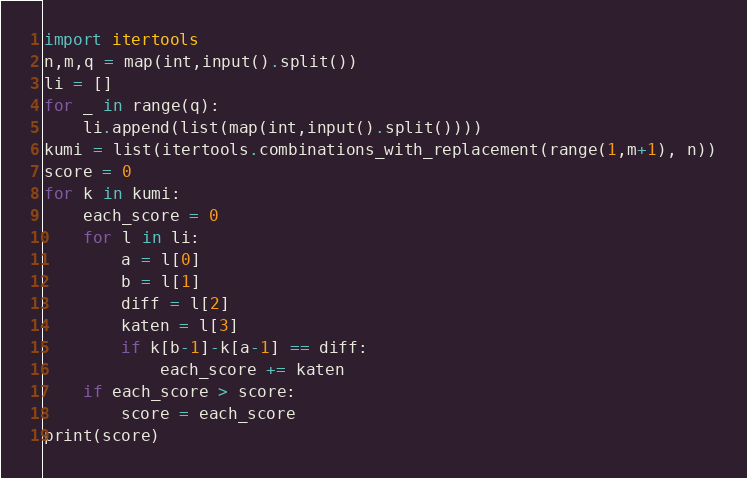Convert code to text. <code><loc_0><loc_0><loc_500><loc_500><_Python_>import itertools
n,m,q = map(int,input().split())
li = []
for _ in range(q):
    li.append(list(map(int,input().split())))
kumi = list(itertools.combinations_with_replacement(range(1,m+1), n))
score = 0
for k in kumi:
    each_score = 0
    for l in li:
        a = l[0]
        b = l[1]
        diff = l[2]
        katen = l[3]
        if k[b-1]-k[a-1] == diff:
            each_score += katen
    if each_score > score:
        score = each_score
print(score)</code> 